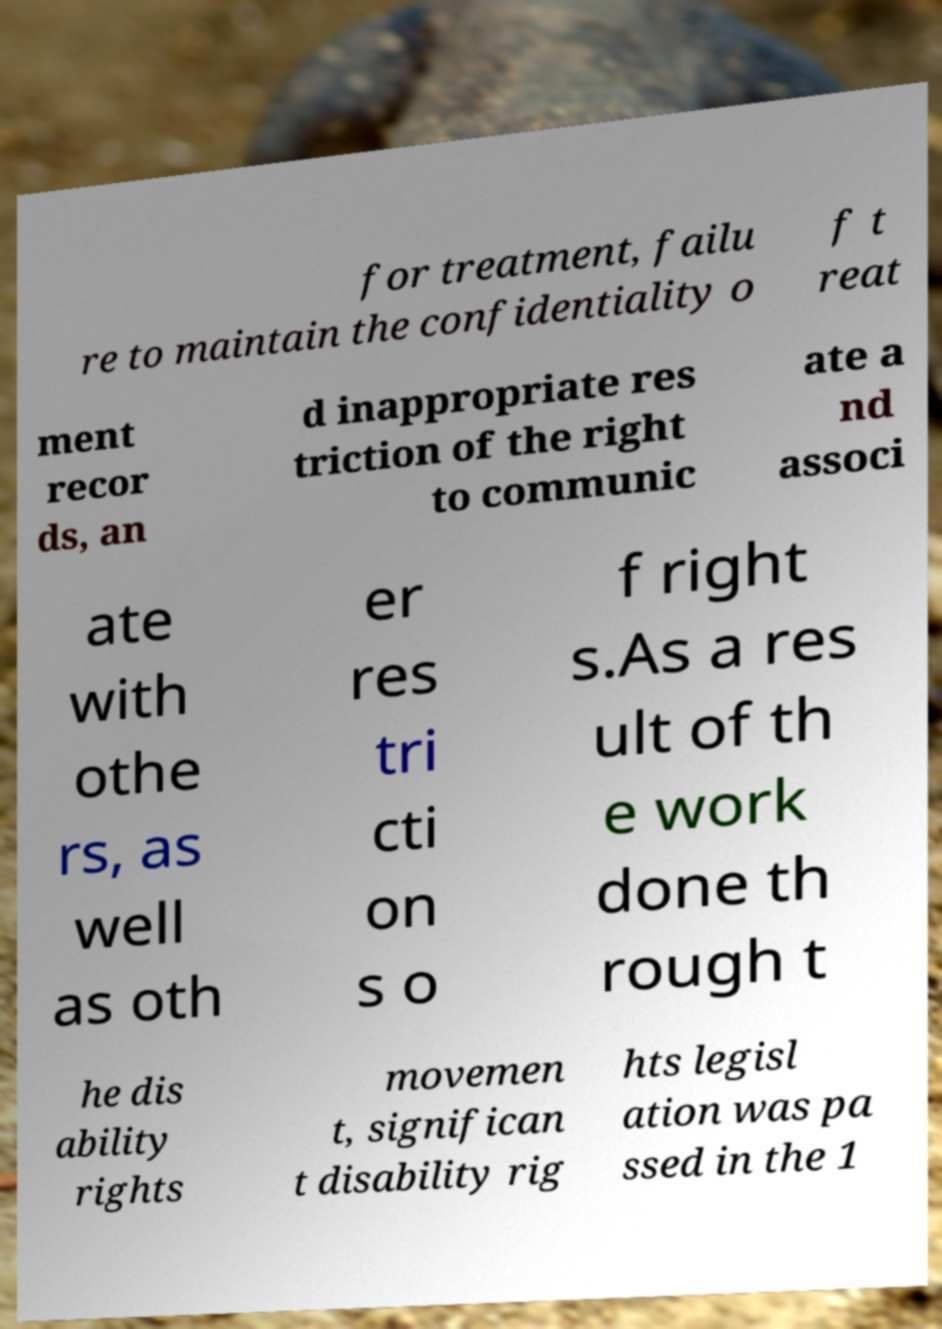What messages or text are displayed in this image? I need them in a readable, typed format. for treatment, failu re to maintain the confidentiality o f t reat ment recor ds, an d inappropriate res triction of the right to communic ate a nd associ ate with othe rs, as well as oth er res tri cti on s o f right s.As a res ult of th e work done th rough t he dis ability rights movemen t, significan t disability rig hts legisl ation was pa ssed in the 1 